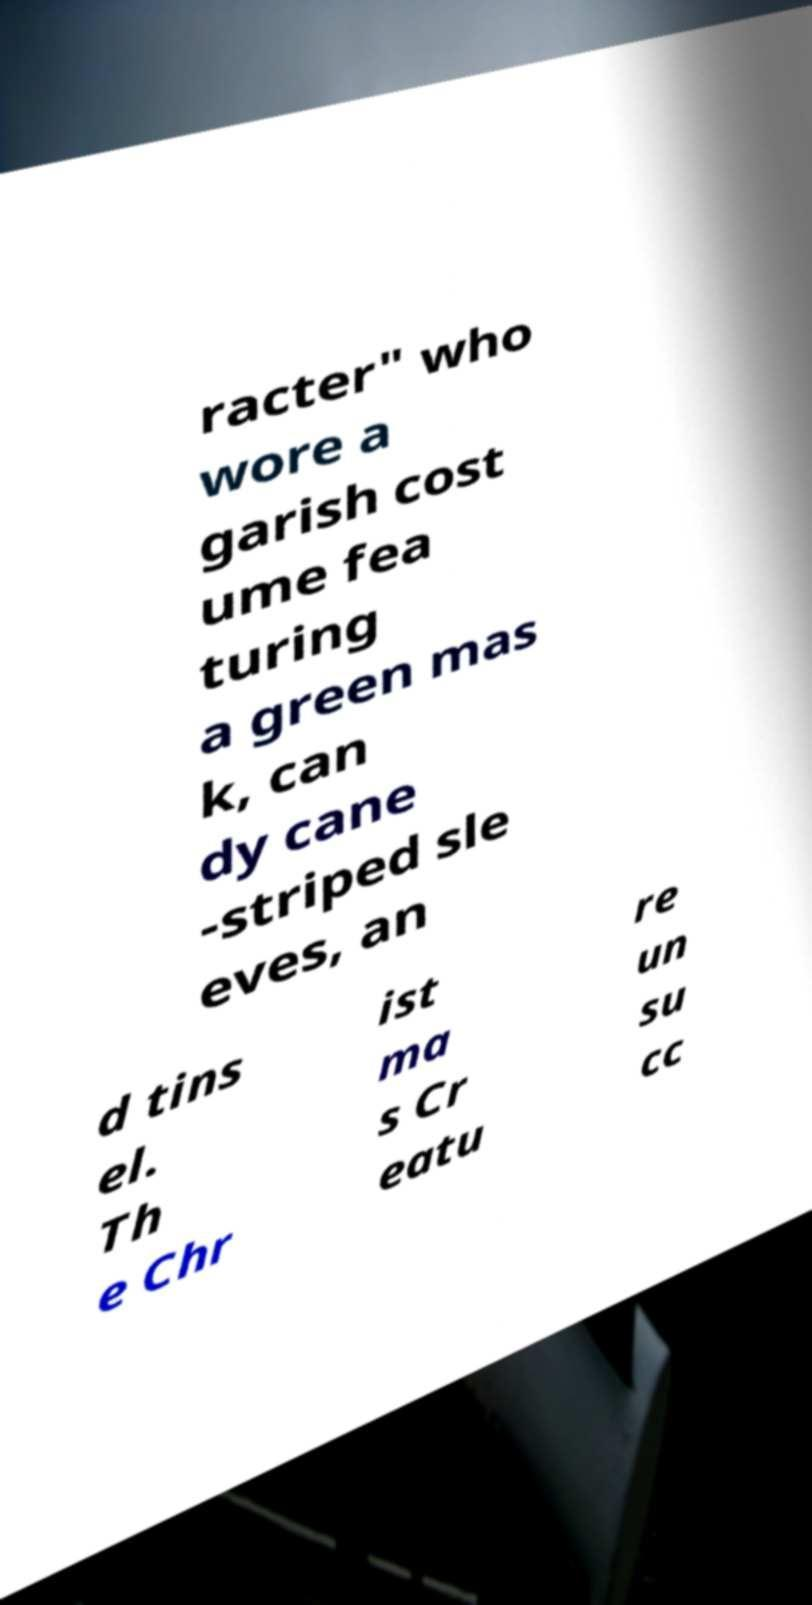There's text embedded in this image that I need extracted. Can you transcribe it verbatim? racter" who wore a garish cost ume fea turing a green mas k, can dy cane -striped sle eves, an d tins el. Th e Chr ist ma s Cr eatu re un su cc 